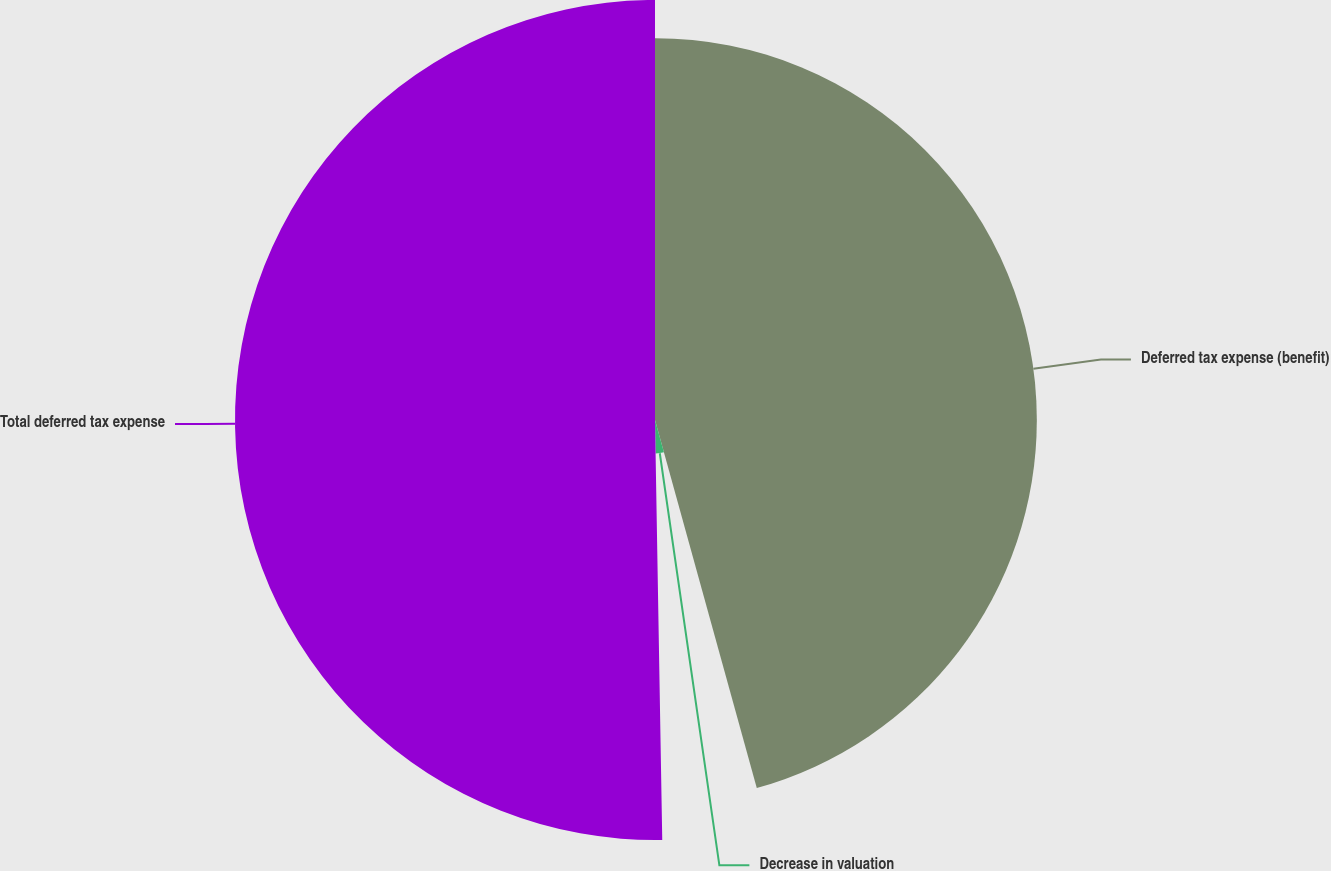<chart> <loc_0><loc_0><loc_500><loc_500><pie_chart><fcel>Deferred tax expense (benefit)<fcel>Decrease in valuation<fcel>Total deferred tax expense<nl><fcel>45.71%<fcel>4.02%<fcel>50.28%<nl></chart> 